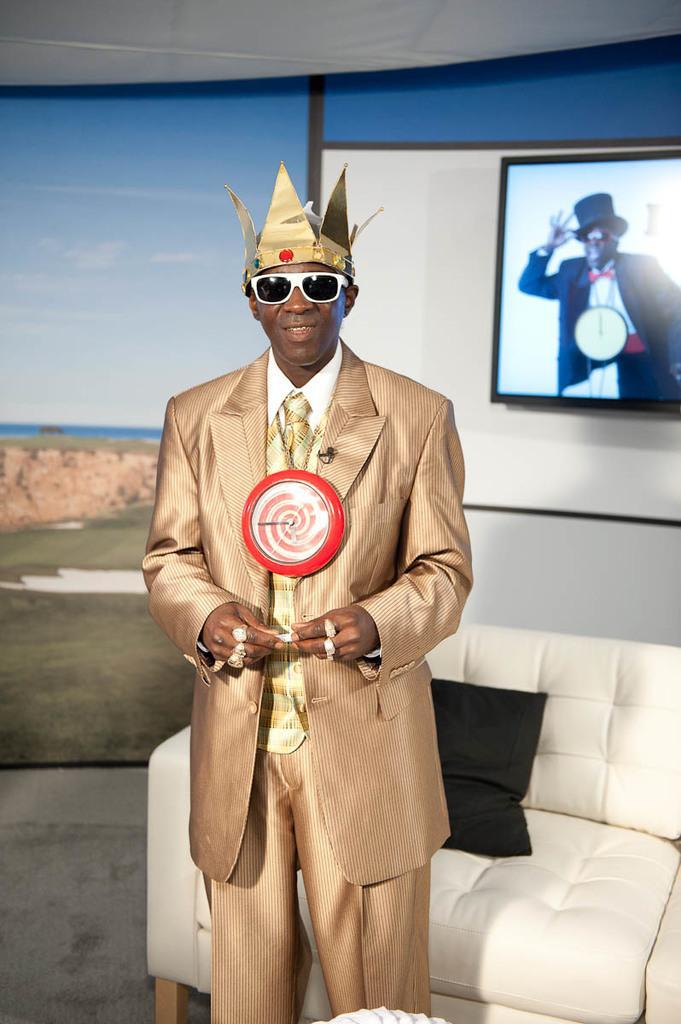In one or two sentences, can you explain what this image depicts? In this picture I can see there is man standing here and he is wearing a blazer and finger rings and he is wearing a crown and a clock, there is a couch and there is a pillow on the couch. In the backdrop there is a wall with a photo frame on the wall. There is a wall here with a poster, it has a mountain, ocean and sky is clear. 